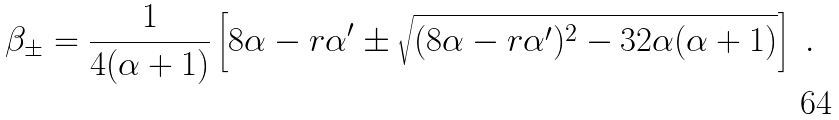<formula> <loc_0><loc_0><loc_500><loc_500>\beta _ { \pm } = \frac { 1 } { 4 ( \alpha + 1 ) } \left [ 8 \alpha - r \alpha ^ { \prime } \pm \sqrt { ( 8 \alpha - r \alpha ^ { \prime } ) ^ { 2 } - 3 2 \alpha ( \alpha + 1 ) } \right ] \ .</formula> 